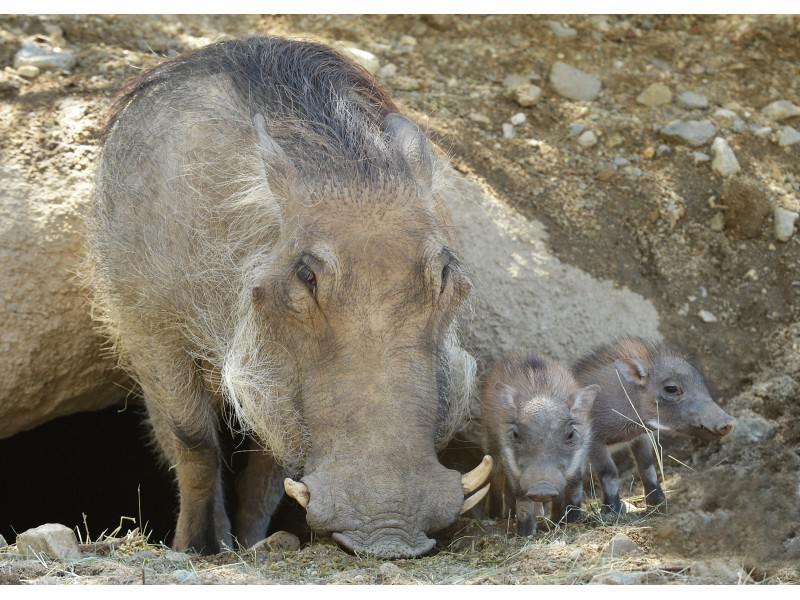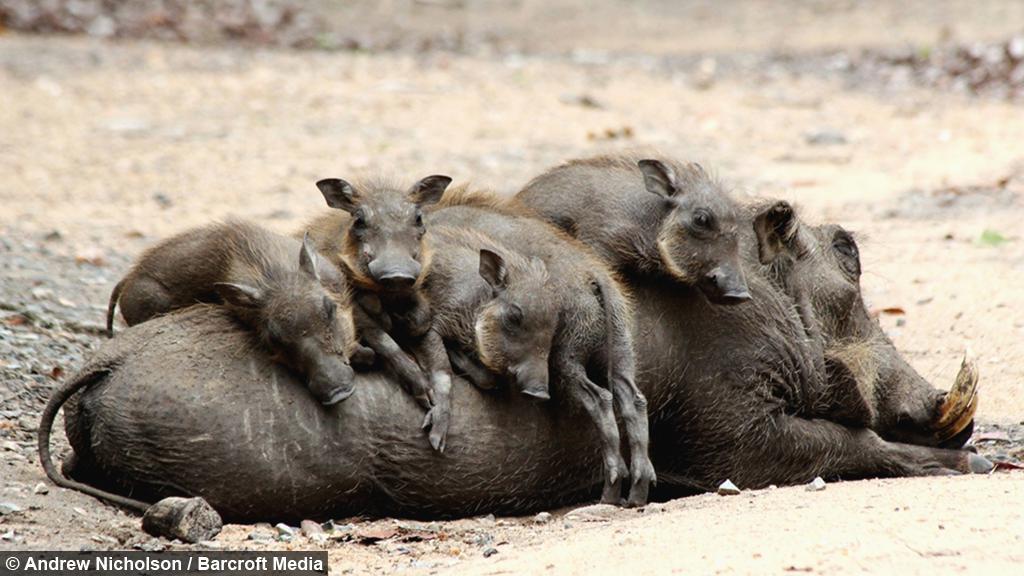The first image is the image on the left, the second image is the image on the right. Evaluate the accuracy of this statement regarding the images: "The right image contains no more than two wart hogs.". Is it true? Answer yes or no. No. The first image is the image on the left, the second image is the image on the right. Examine the images to the left and right. Is the description "At least one warthog is wading in mud in one of the images." accurate? Answer yes or no. No. 